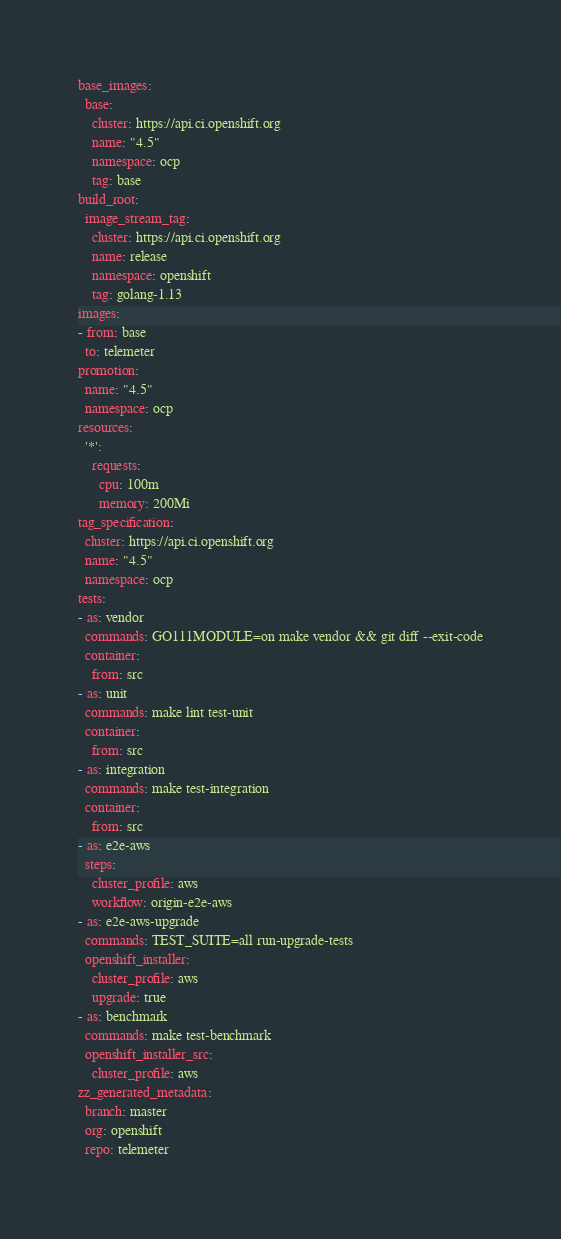Convert code to text. <code><loc_0><loc_0><loc_500><loc_500><_YAML_>base_images:
  base:
    cluster: https://api.ci.openshift.org
    name: "4.5"
    namespace: ocp
    tag: base
build_root:
  image_stream_tag:
    cluster: https://api.ci.openshift.org
    name: release
    namespace: openshift
    tag: golang-1.13
images:
- from: base
  to: telemeter
promotion:
  name: "4.5"
  namespace: ocp
resources:
  '*':
    requests:
      cpu: 100m
      memory: 200Mi
tag_specification:
  cluster: https://api.ci.openshift.org
  name: "4.5"
  namespace: ocp
tests:
- as: vendor
  commands: GO111MODULE=on make vendor && git diff --exit-code
  container:
    from: src
- as: unit
  commands: make lint test-unit
  container:
    from: src
- as: integration
  commands: make test-integration
  container:
    from: src
- as: e2e-aws
  steps:
    cluster_profile: aws
    workflow: origin-e2e-aws
- as: e2e-aws-upgrade
  commands: TEST_SUITE=all run-upgrade-tests
  openshift_installer:
    cluster_profile: aws
    upgrade: true
- as: benchmark
  commands: make test-benchmark
  openshift_installer_src:
    cluster_profile: aws
zz_generated_metadata:
  branch: master
  org: openshift
  repo: telemeter
</code> 